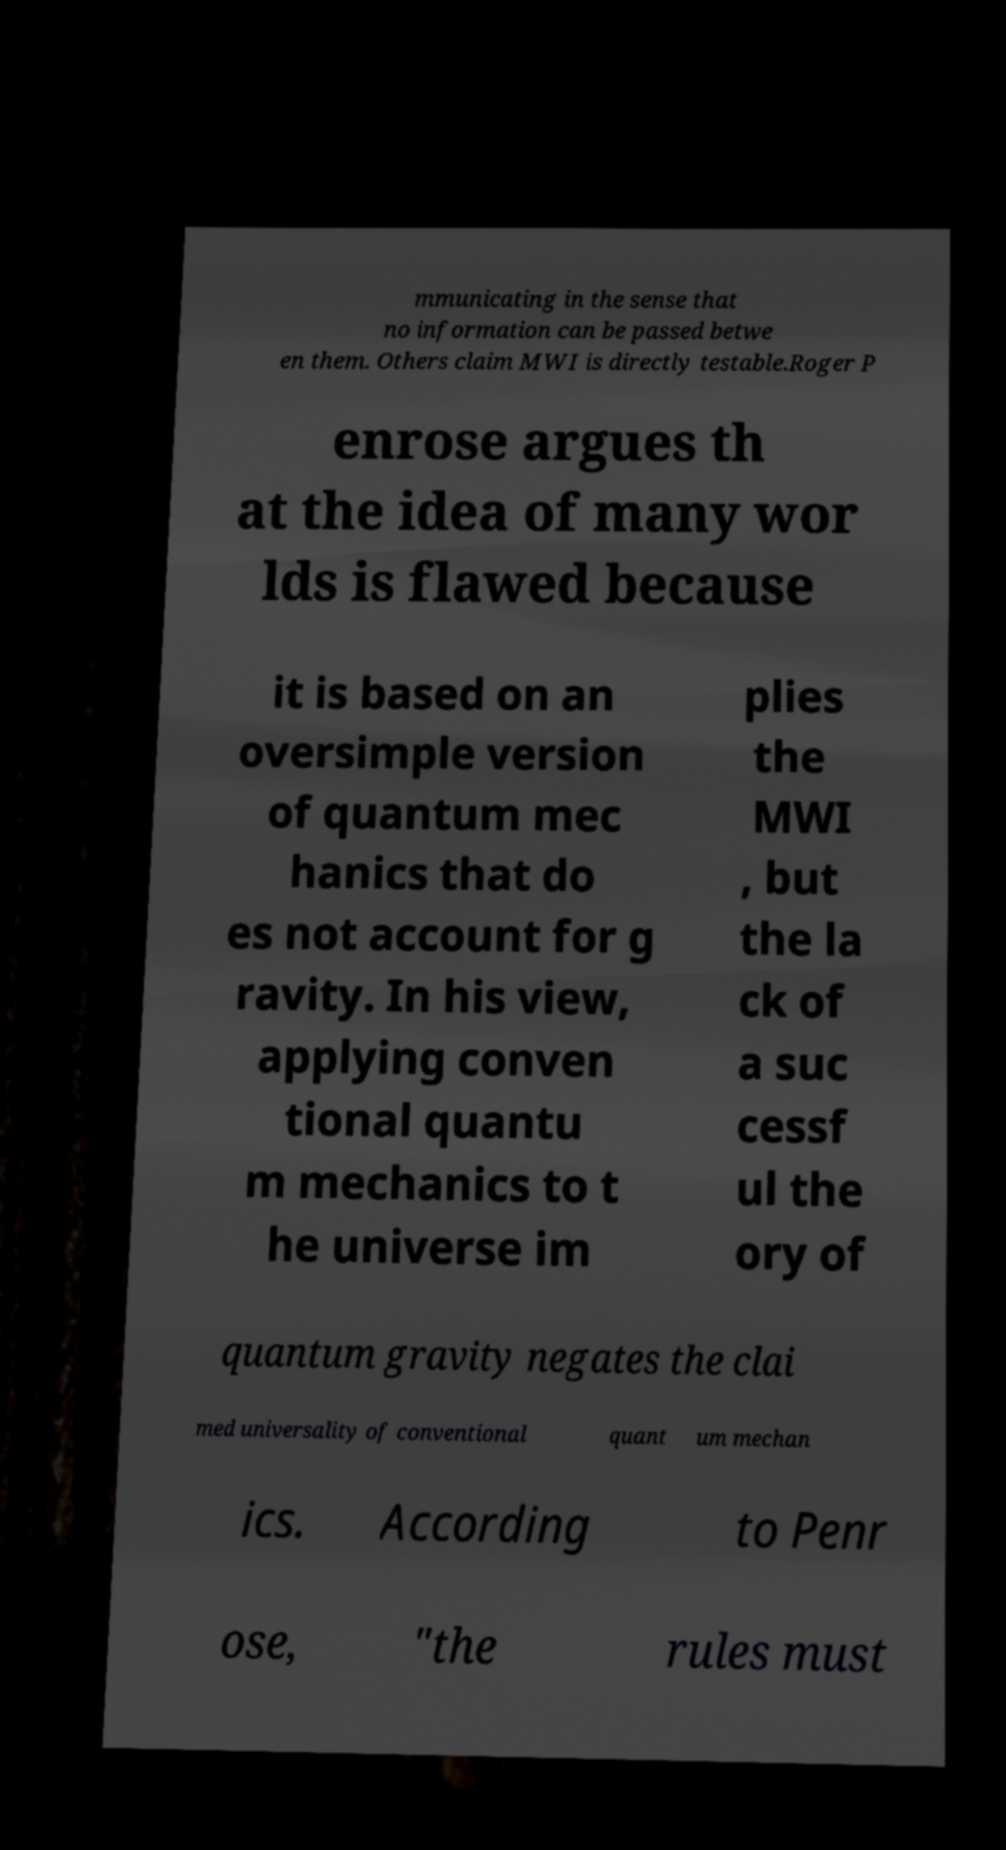Please identify and transcribe the text found in this image. mmunicating in the sense that no information can be passed betwe en them. Others claim MWI is directly testable.Roger P enrose argues th at the idea of many wor lds is flawed because it is based on an oversimple version of quantum mec hanics that do es not account for g ravity. In his view, applying conven tional quantu m mechanics to t he universe im plies the MWI , but the la ck of a suc cessf ul the ory of quantum gravity negates the clai med universality of conventional quant um mechan ics. According to Penr ose, "the rules must 